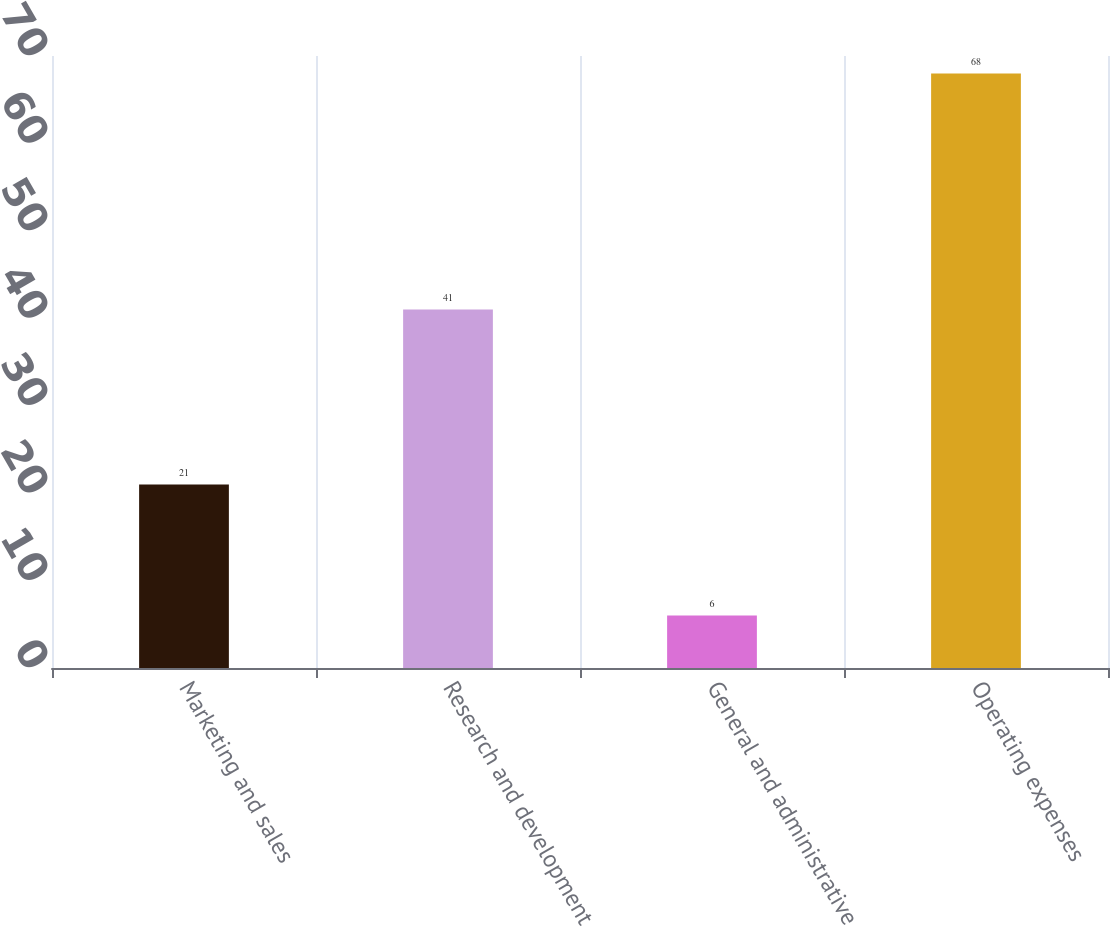Convert chart. <chart><loc_0><loc_0><loc_500><loc_500><bar_chart><fcel>Marketing and sales<fcel>Research and development<fcel>General and administrative<fcel>Operating expenses<nl><fcel>21<fcel>41<fcel>6<fcel>68<nl></chart> 